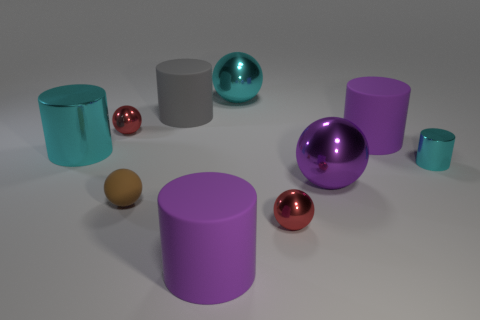Subtract 2 cylinders. How many cylinders are left? 3 Subtract all gray cylinders. How many cylinders are left? 4 Subtract all large purple balls. How many balls are left? 4 Subtract all blue cylinders. Subtract all blue cubes. How many cylinders are left? 5 Subtract 0 blue cylinders. How many objects are left? 10 Subtract all tiny metallic spheres. Subtract all tiny shiny objects. How many objects are left? 5 Add 3 big rubber cylinders. How many big rubber cylinders are left? 6 Add 7 brown things. How many brown things exist? 8 